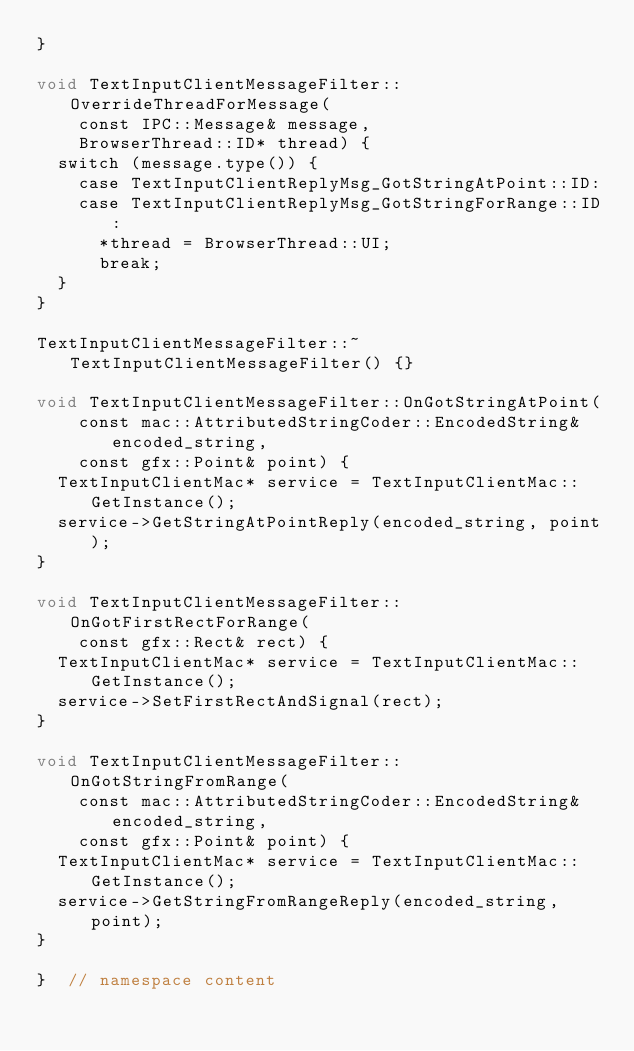Convert code to text. <code><loc_0><loc_0><loc_500><loc_500><_ObjectiveC_>}

void TextInputClientMessageFilter::OverrideThreadForMessage(
    const IPC::Message& message,
    BrowserThread::ID* thread) {
  switch (message.type()) {
    case TextInputClientReplyMsg_GotStringAtPoint::ID:
    case TextInputClientReplyMsg_GotStringForRange::ID:
      *thread = BrowserThread::UI;
      break;
  }
}

TextInputClientMessageFilter::~TextInputClientMessageFilter() {}

void TextInputClientMessageFilter::OnGotStringAtPoint(
    const mac::AttributedStringCoder::EncodedString& encoded_string,
    const gfx::Point& point) {
  TextInputClientMac* service = TextInputClientMac::GetInstance();
  service->GetStringAtPointReply(encoded_string, point);
}

void TextInputClientMessageFilter::OnGotFirstRectForRange(
    const gfx::Rect& rect) {
  TextInputClientMac* service = TextInputClientMac::GetInstance();
  service->SetFirstRectAndSignal(rect);
}

void TextInputClientMessageFilter::OnGotStringFromRange(
    const mac::AttributedStringCoder::EncodedString& encoded_string,
    const gfx::Point& point) {
  TextInputClientMac* service = TextInputClientMac::GetInstance();
  service->GetStringFromRangeReply(encoded_string, point);
}

}  // namespace content
</code> 